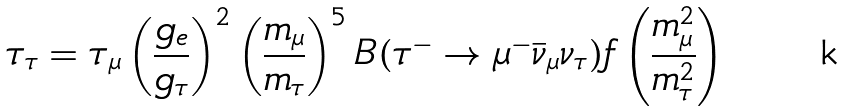<formula> <loc_0><loc_0><loc_500><loc_500>\tau _ { \tau } = \tau _ { \mu } \left ( \frac { g _ { e } } { g _ { \tau } } \right ) ^ { 2 } \left ( \frac { m _ { \mu } } { m _ { \tau } } \right ) ^ { 5 } B ( \tau ^ { - } \to \mu ^ { - } { \bar { \nu } _ { \mu } } \nu _ { \tau } ) f \left ( \frac { m ^ { 2 } _ { \mu } } { m ^ { 2 } _ { \tau } } \right )</formula> 